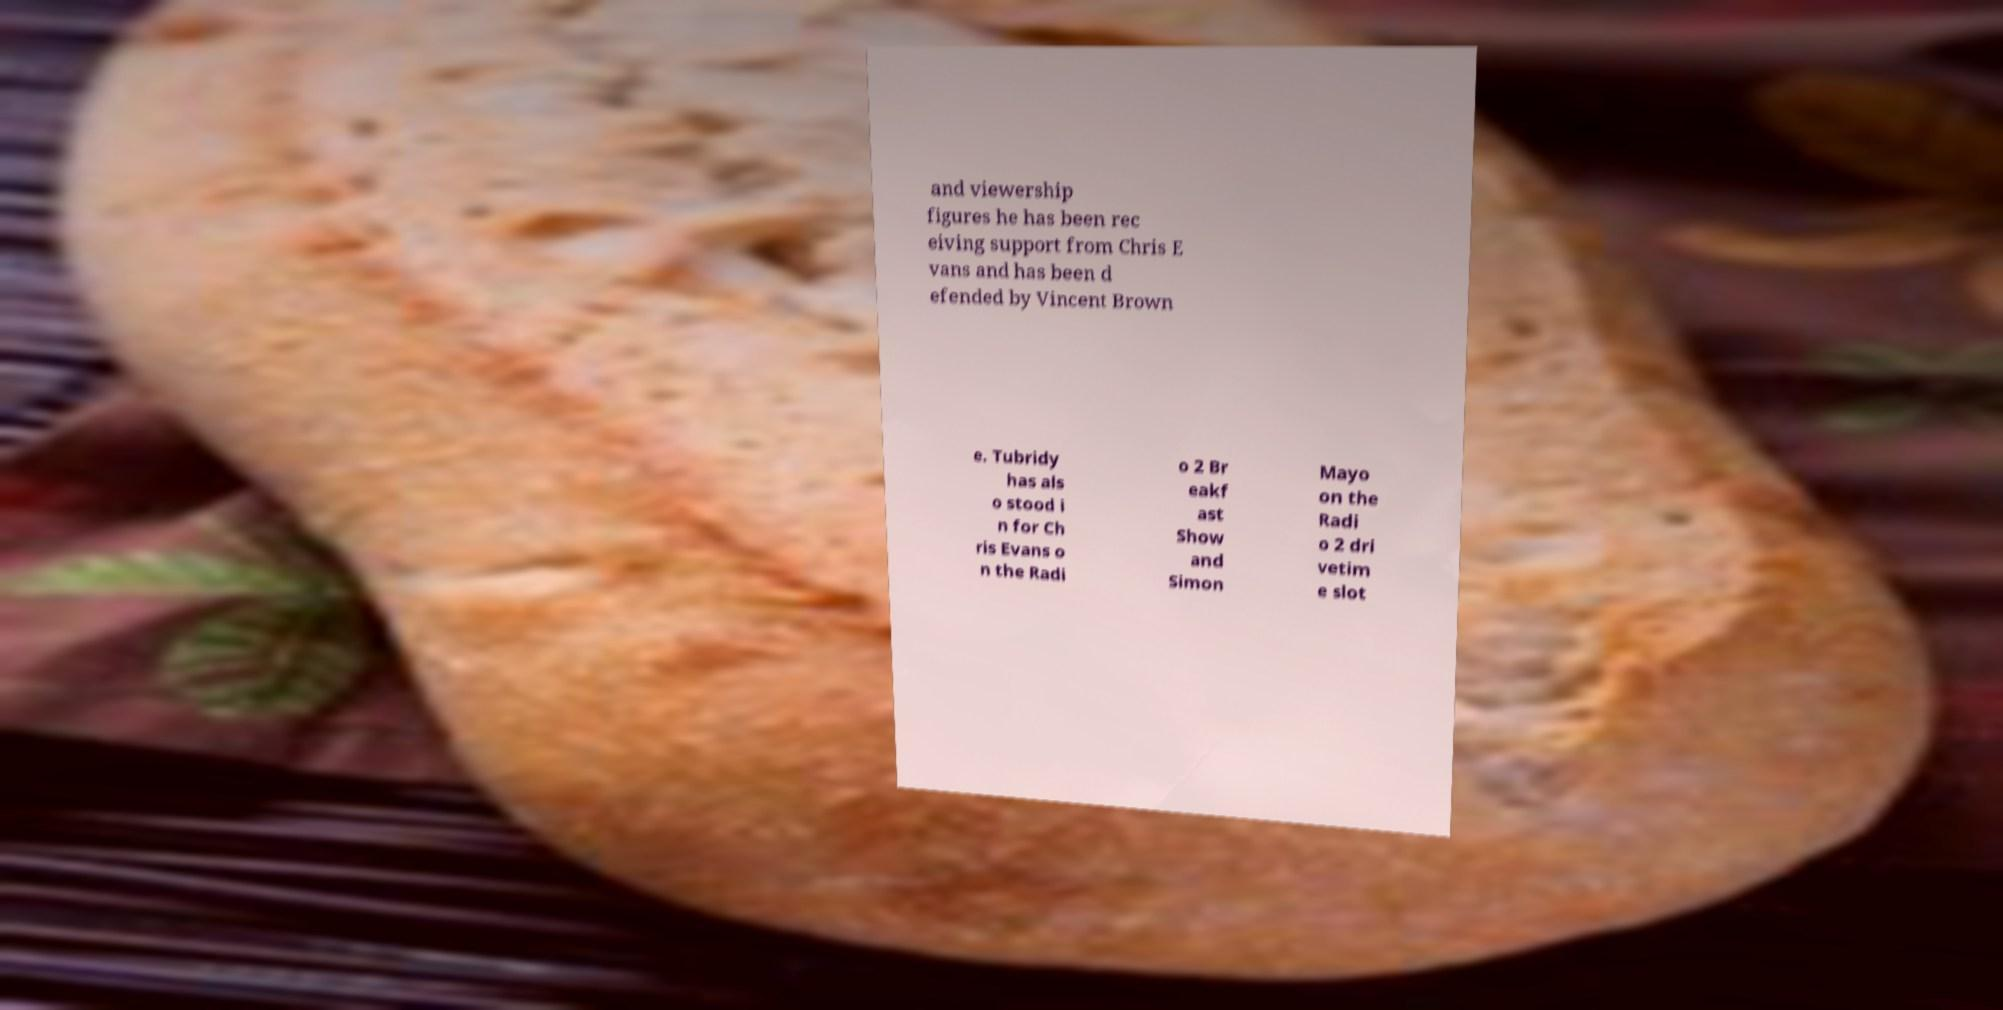For documentation purposes, I need the text within this image transcribed. Could you provide that? and viewership figures he has been rec eiving support from Chris E vans and has been d efended by Vincent Brown e. Tubridy has als o stood i n for Ch ris Evans o n the Radi o 2 Br eakf ast Show and Simon Mayo on the Radi o 2 dri vetim e slot 